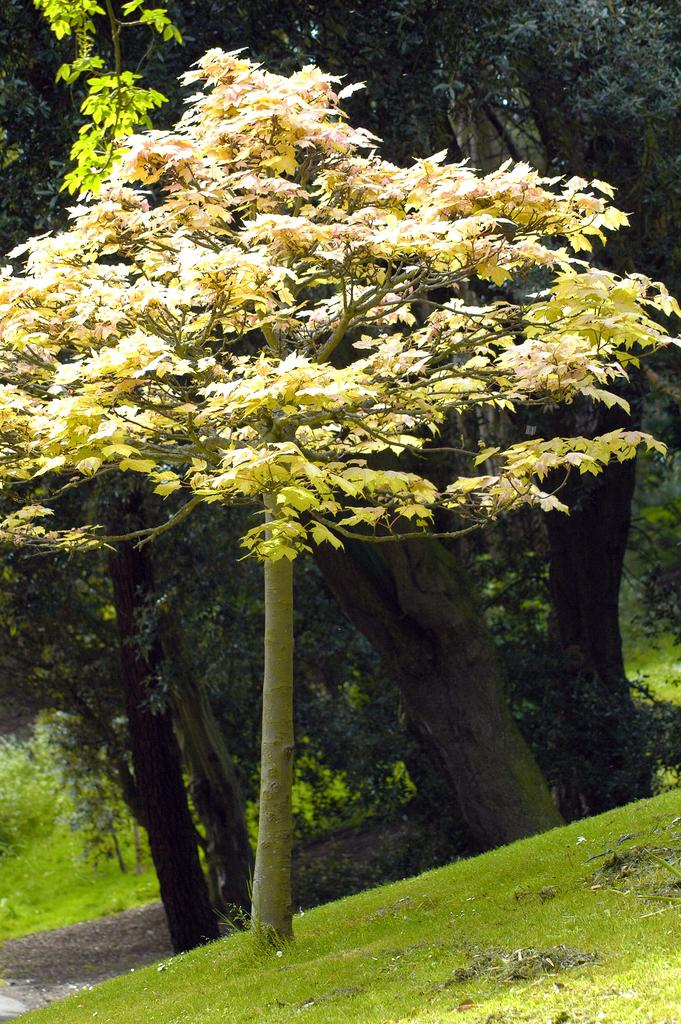What type of vegetation can be seen in the image? There are trees and grass in the image. Can you describe the natural environment depicted in the image? The image features trees and grass, which are common elements of natural landscapes. How far away is the ear from the thought in the image? There is no ear or thought present in the image; it only features trees and grass. 